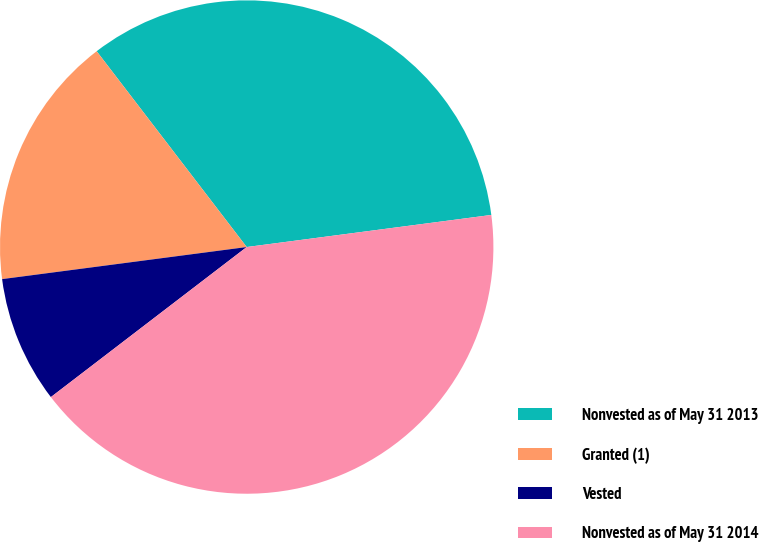Convert chart. <chart><loc_0><loc_0><loc_500><loc_500><pie_chart><fcel>Nonvested as of May 31 2013<fcel>Granted (1)<fcel>Vested<fcel>Nonvested as of May 31 2014<nl><fcel>33.33%<fcel>16.67%<fcel>8.33%<fcel>41.67%<nl></chart> 